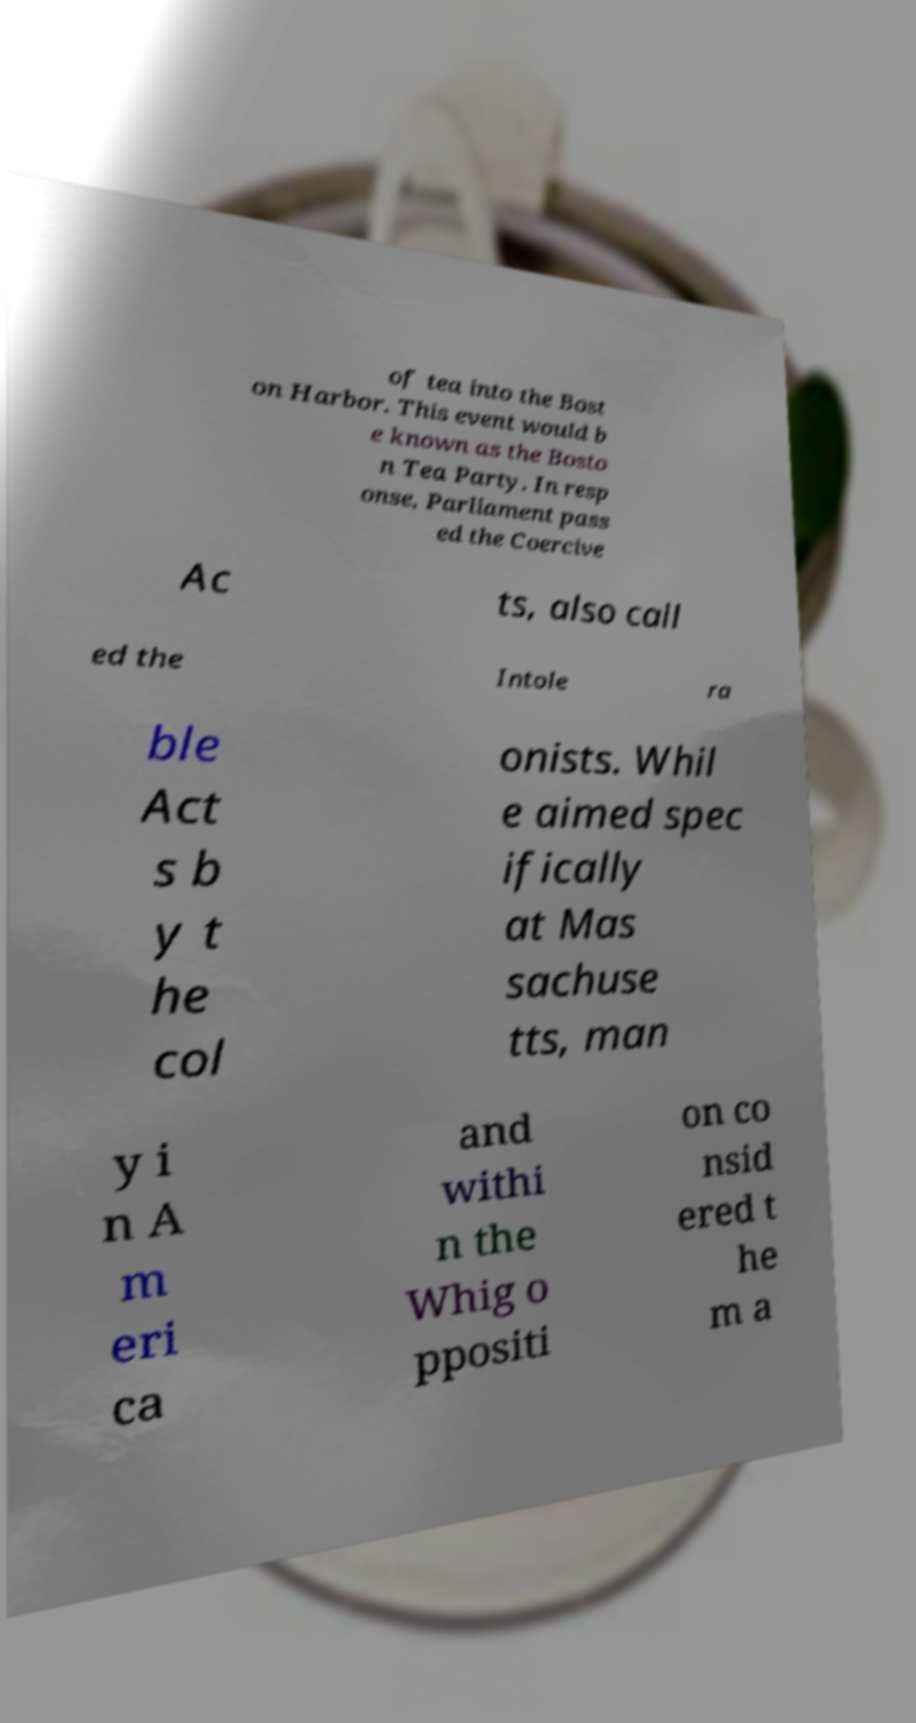Please identify and transcribe the text found in this image. of tea into the Bost on Harbor. This event would b e known as the Bosto n Tea Party. In resp onse, Parliament pass ed the Coercive Ac ts, also call ed the Intole ra ble Act s b y t he col onists. Whil e aimed spec ifically at Mas sachuse tts, man y i n A m eri ca and withi n the Whig o ppositi on co nsid ered t he m a 